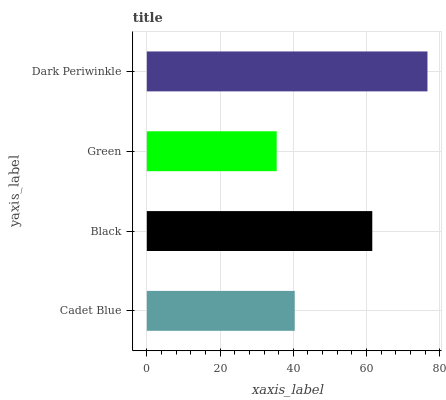Is Green the minimum?
Answer yes or no. Yes. Is Dark Periwinkle the maximum?
Answer yes or no. Yes. Is Black the minimum?
Answer yes or no. No. Is Black the maximum?
Answer yes or no. No. Is Black greater than Cadet Blue?
Answer yes or no. Yes. Is Cadet Blue less than Black?
Answer yes or no. Yes. Is Cadet Blue greater than Black?
Answer yes or no. No. Is Black less than Cadet Blue?
Answer yes or no. No. Is Black the high median?
Answer yes or no. Yes. Is Cadet Blue the low median?
Answer yes or no. Yes. Is Cadet Blue the high median?
Answer yes or no. No. Is Dark Periwinkle the low median?
Answer yes or no. No. 